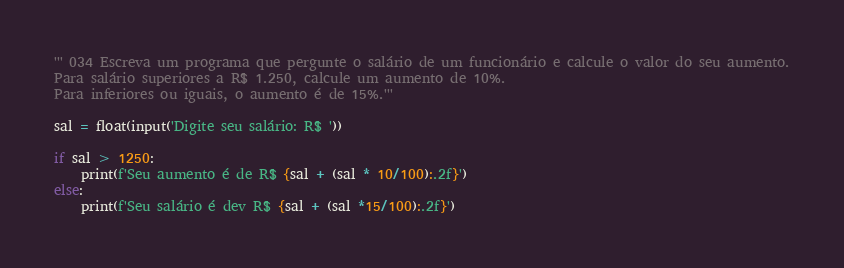Convert code to text. <code><loc_0><loc_0><loc_500><loc_500><_Python_>''' 034 Escreva um programa que pergunte o salário de um funcionário e calcule o valor do seu aumento.
Para salário superiores a R$ 1.250, calcule um aumento de 10%.
Para inferiores ou iguais, o aumento é de 15%.'''

sal = float(input('Digite seu salário: R$ '))

if sal > 1250:
    print(f'Seu aumento é de R$ {sal + (sal * 10/100):.2f}')
else:
    print(f'Seu salário é dev R$ {sal + (sal *15/100):.2f}')</code> 